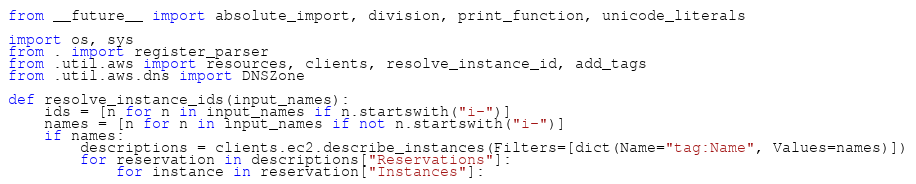<code> <loc_0><loc_0><loc_500><loc_500><_Python_>from __future__ import absolute_import, division, print_function, unicode_literals

import os, sys
from . import register_parser
from .util.aws import resources, clients, resolve_instance_id, add_tags
from .util.aws.dns import DNSZone

def resolve_instance_ids(input_names):
    ids = [n for n in input_names if n.startswith("i-")]
    names = [n for n in input_names if not n.startswith("i-")]
    if names:
        descriptions = clients.ec2.describe_instances(Filters=[dict(Name="tag:Name", Values=names)])
        for reservation in descriptions["Reservations"]:
            for instance in reservation["Instances"]:</code> 